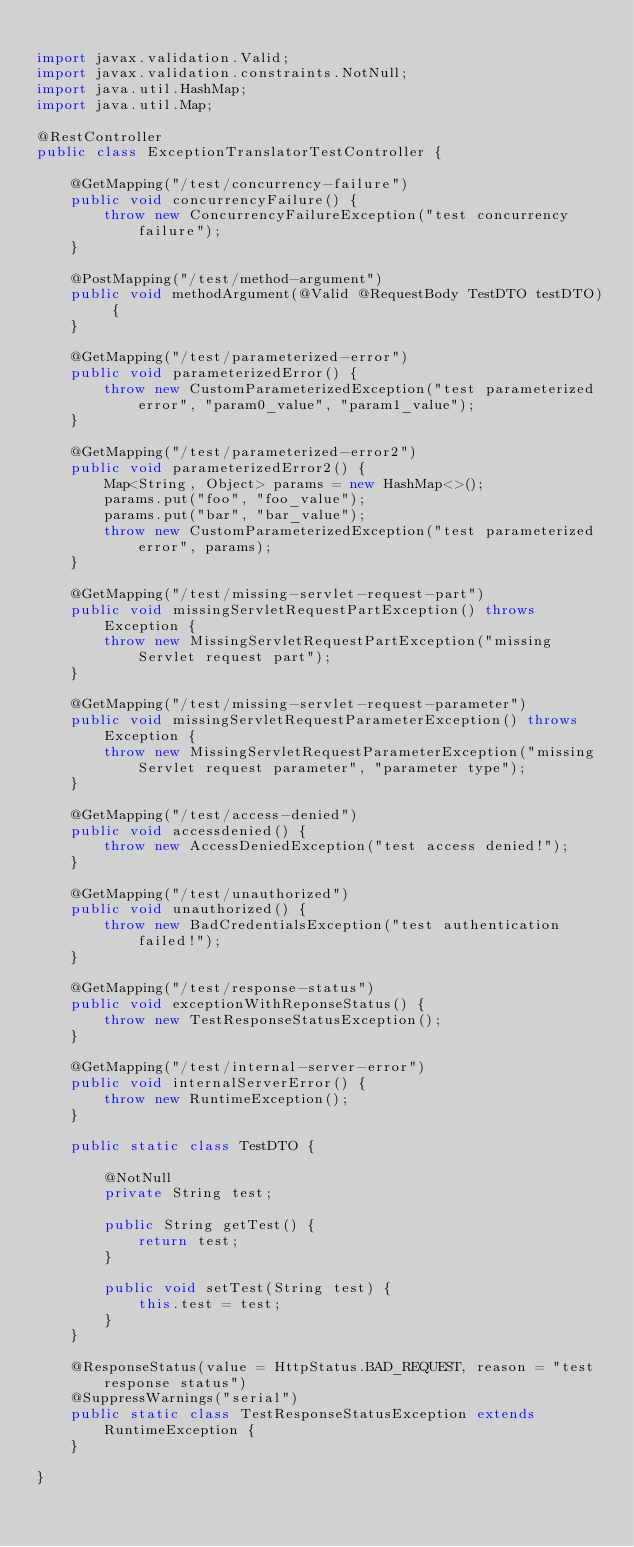<code> <loc_0><loc_0><loc_500><loc_500><_Java_>
import javax.validation.Valid;
import javax.validation.constraints.NotNull;
import java.util.HashMap;
import java.util.Map;

@RestController
public class ExceptionTranslatorTestController {

    @GetMapping("/test/concurrency-failure")
    public void concurrencyFailure() {
        throw new ConcurrencyFailureException("test concurrency failure");
    }

    @PostMapping("/test/method-argument")
    public void methodArgument(@Valid @RequestBody TestDTO testDTO) {
    }

    @GetMapping("/test/parameterized-error")
    public void parameterizedError() {
        throw new CustomParameterizedException("test parameterized error", "param0_value", "param1_value");
    }

    @GetMapping("/test/parameterized-error2")
    public void parameterizedError2() {
        Map<String, Object> params = new HashMap<>();
        params.put("foo", "foo_value");
        params.put("bar", "bar_value");
        throw new CustomParameterizedException("test parameterized error", params);
    }

    @GetMapping("/test/missing-servlet-request-part")
    public void missingServletRequestPartException() throws Exception {
        throw new MissingServletRequestPartException("missing Servlet request part");
    }

    @GetMapping("/test/missing-servlet-request-parameter")
    public void missingServletRequestParameterException() throws Exception {
        throw new MissingServletRequestParameterException("missing Servlet request parameter", "parameter type");
    }

    @GetMapping("/test/access-denied")
    public void accessdenied() {
        throw new AccessDeniedException("test access denied!");
    }

    @GetMapping("/test/unauthorized")
    public void unauthorized() {
        throw new BadCredentialsException("test authentication failed!");
    }

    @GetMapping("/test/response-status")
    public void exceptionWithReponseStatus() {
        throw new TestResponseStatusException();
    }

    @GetMapping("/test/internal-server-error")
    public void internalServerError() {
        throw new RuntimeException();
    }

    public static class TestDTO {

        @NotNull
        private String test;

        public String getTest() {
            return test;
        }

        public void setTest(String test) {
            this.test = test;
        }
    }

    @ResponseStatus(value = HttpStatus.BAD_REQUEST, reason = "test response status")
    @SuppressWarnings("serial")
    public static class TestResponseStatusException extends RuntimeException {
    }

}
</code> 